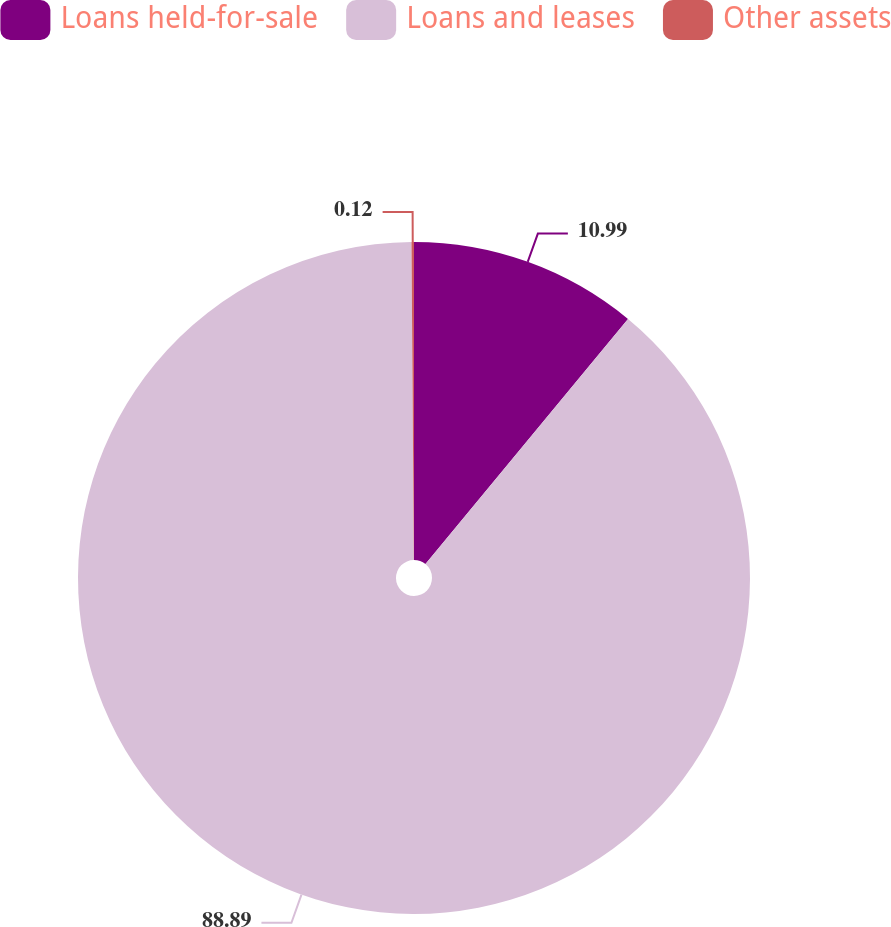Convert chart. <chart><loc_0><loc_0><loc_500><loc_500><pie_chart><fcel>Loans held-for-sale<fcel>Loans and leases<fcel>Other assets<nl><fcel>10.99%<fcel>88.89%<fcel>0.12%<nl></chart> 